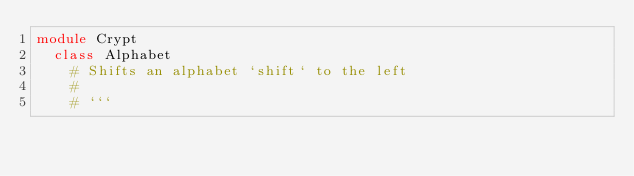<code> <loc_0><loc_0><loc_500><loc_500><_Crystal_>module Crypt
  class Alphabet
    # Shifts an alphabet `shift` to the left
    # 
    # ```</code> 